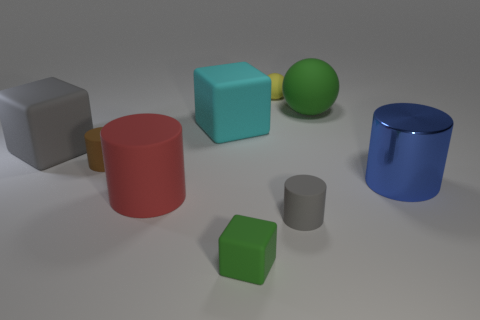What is the material of the gray block that is the same size as the cyan matte cube?
Keep it short and to the point. Rubber. What size is the rubber ball that is behind the big matte thing that is to the right of the gray object in front of the blue shiny object?
Your answer should be very brief. Small. Does the cube in front of the blue cylinder have the same color as the big rubber thing that is to the right of the tiny block?
Make the answer very short. Yes. How many purple things are either shiny objects or small cubes?
Provide a short and direct response. 0. How many gray matte things are the same size as the yellow rubber sphere?
Give a very brief answer. 1. Is the tiny cylinder that is left of the small yellow object made of the same material as the tiny green block?
Provide a succinct answer. Yes. Are there any large gray rubber things that are in front of the large cylinder right of the green matte ball?
Offer a terse response. No. There is a blue thing that is the same shape as the big red thing; what material is it?
Offer a terse response. Metal. Is the number of green objects that are in front of the small gray matte object greater than the number of yellow objects on the left side of the red rubber cylinder?
Give a very brief answer. Yes. What is the shape of the small brown thing that is made of the same material as the big cyan block?
Your answer should be compact. Cylinder. 